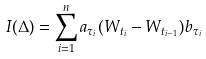Convert formula to latex. <formula><loc_0><loc_0><loc_500><loc_500>I ( \Delta ) = \sum _ { i = 1 } ^ { n } a _ { \tau _ { i } } ( W _ { t _ { i } } - W _ { t _ { i - 1 } } ) b _ { \tau _ { i } }</formula> 